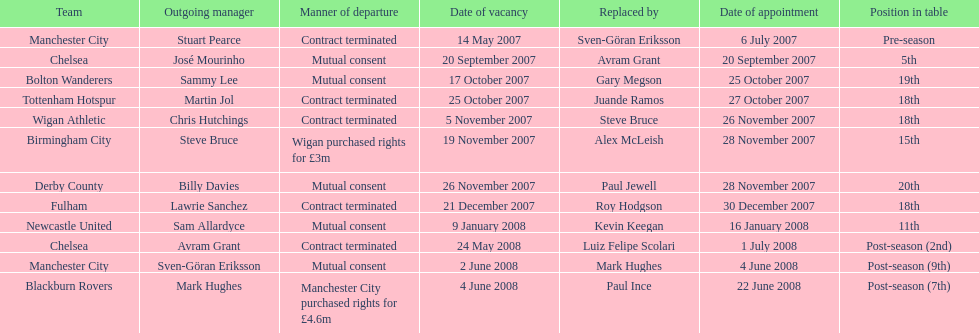What is the team listed following manchester city? Chelsea. Help me parse the entirety of this table. {'header': ['Team', 'Outgoing manager', 'Manner of departure', 'Date of vacancy', 'Replaced by', 'Date of appointment', 'Position in table'], 'rows': [['Manchester City', 'Stuart Pearce', 'Contract terminated', '14 May 2007', 'Sven-Göran Eriksson', '6 July 2007', 'Pre-season'], ['Chelsea', 'José Mourinho', 'Mutual consent', '20 September 2007', 'Avram Grant', '20 September 2007', '5th'], ['Bolton Wanderers', 'Sammy Lee', 'Mutual consent', '17 October 2007', 'Gary Megson', '25 October 2007', '19th'], ['Tottenham Hotspur', 'Martin Jol', 'Contract terminated', '25 October 2007', 'Juande Ramos', '27 October 2007', '18th'], ['Wigan Athletic', 'Chris Hutchings', 'Contract terminated', '5 November 2007', 'Steve Bruce', '26 November 2007', '18th'], ['Birmingham City', 'Steve Bruce', 'Wigan purchased rights for £3m', '19 November 2007', 'Alex McLeish', '28 November 2007', '15th'], ['Derby County', 'Billy Davies', 'Mutual consent', '26 November 2007', 'Paul Jewell', '28 November 2007', '20th'], ['Fulham', 'Lawrie Sanchez', 'Contract terminated', '21 December 2007', 'Roy Hodgson', '30 December 2007', '18th'], ['Newcastle United', 'Sam Allardyce', 'Mutual consent', '9 January 2008', 'Kevin Keegan', '16 January 2008', '11th'], ['Chelsea', 'Avram Grant', 'Contract terminated', '24 May 2008', 'Luiz Felipe Scolari', '1 July 2008', 'Post-season (2nd)'], ['Manchester City', 'Sven-Göran Eriksson', 'Mutual consent', '2 June 2008', 'Mark Hughes', '4 June 2008', 'Post-season (9th)'], ['Blackburn Rovers', 'Mark Hughes', 'Manchester City purchased rights for £4.6m', '4 June 2008', 'Paul Ince', '22 June 2008', 'Post-season (7th)']]} 